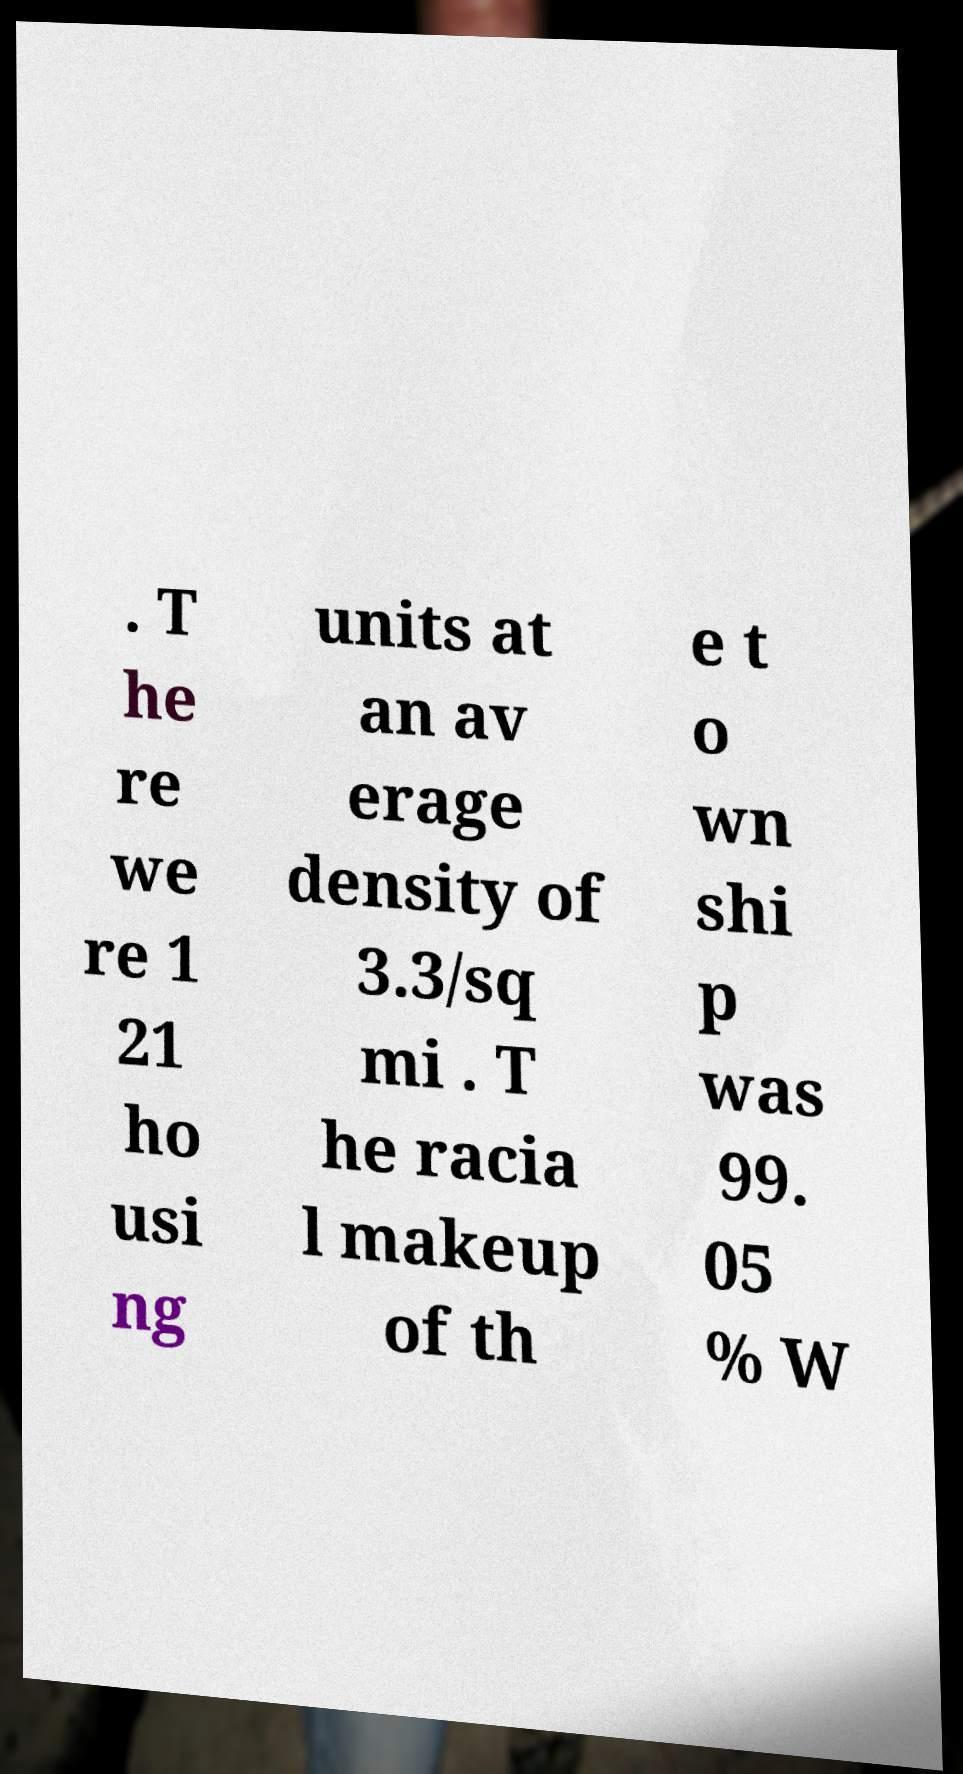Please read and relay the text visible in this image. What does it say? . T he re we re 1 21 ho usi ng units at an av erage density of 3.3/sq mi . T he racia l makeup of th e t o wn shi p was 99. 05 % W 